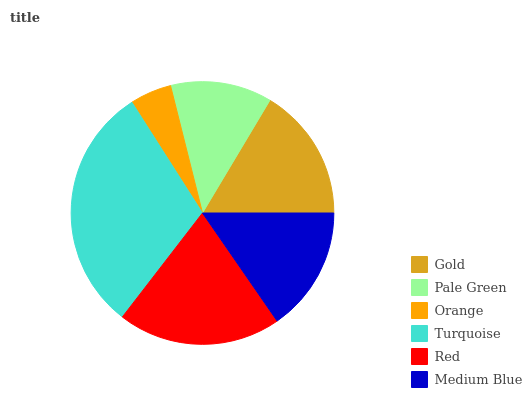Is Orange the minimum?
Answer yes or no. Yes. Is Turquoise the maximum?
Answer yes or no. Yes. Is Pale Green the minimum?
Answer yes or no. No. Is Pale Green the maximum?
Answer yes or no. No. Is Gold greater than Pale Green?
Answer yes or no. Yes. Is Pale Green less than Gold?
Answer yes or no. Yes. Is Pale Green greater than Gold?
Answer yes or no. No. Is Gold less than Pale Green?
Answer yes or no. No. Is Gold the high median?
Answer yes or no. Yes. Is Medium Blue the low median?
Answer yes or no. Yes. Is Turquoise the high median?
Answer yes or no. No. Is Pale Green the low median?
Answer yes or no. No. 